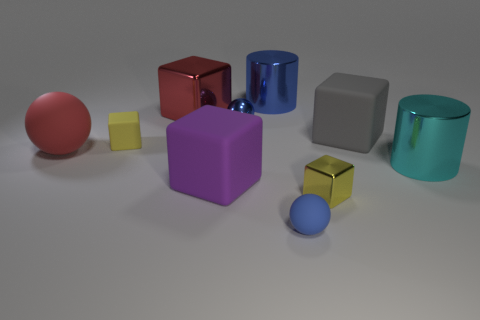What is the color of the large metallic cylinder in front of the large shiny cylinder that is left of the large gray thing?
Your answer should be compact. Cyan. Are there any large shiny cubes that have the same color as the shiny sphere?
Ensure brevity in your answer.  No. There is a yellow matte object to the left of the blue ball behind the rubber sphere that is to the right of the big red metal object; what is its size?
Offer a very short reply. Small. Does the large purple object have the same shape as the big rubber object to the right of the big purple object?
Provide a short and direct response. Yes. How many other objects are there of the same size as the blue rubber ball?
Make the answer very short. 3. There is a red ball left of the big purple rubber thing; what is its size?
Ensure brevity in your answer.  Large. What number of tiny blue spheres have the same material as the big red block?
Offer a terse response. 1. Is the shape of the tiny shiny thing that is behind the big red matte sphere the same as  the big cyan shiny object?
Your response must be concise. No. There is a shiny thing that is to the right of the tiny metallic block; what shape is it?
Give a very brief answer. Cylinder. What size is the object that is the same color as the large matte ball?
Your answer should be very brief. Large. 